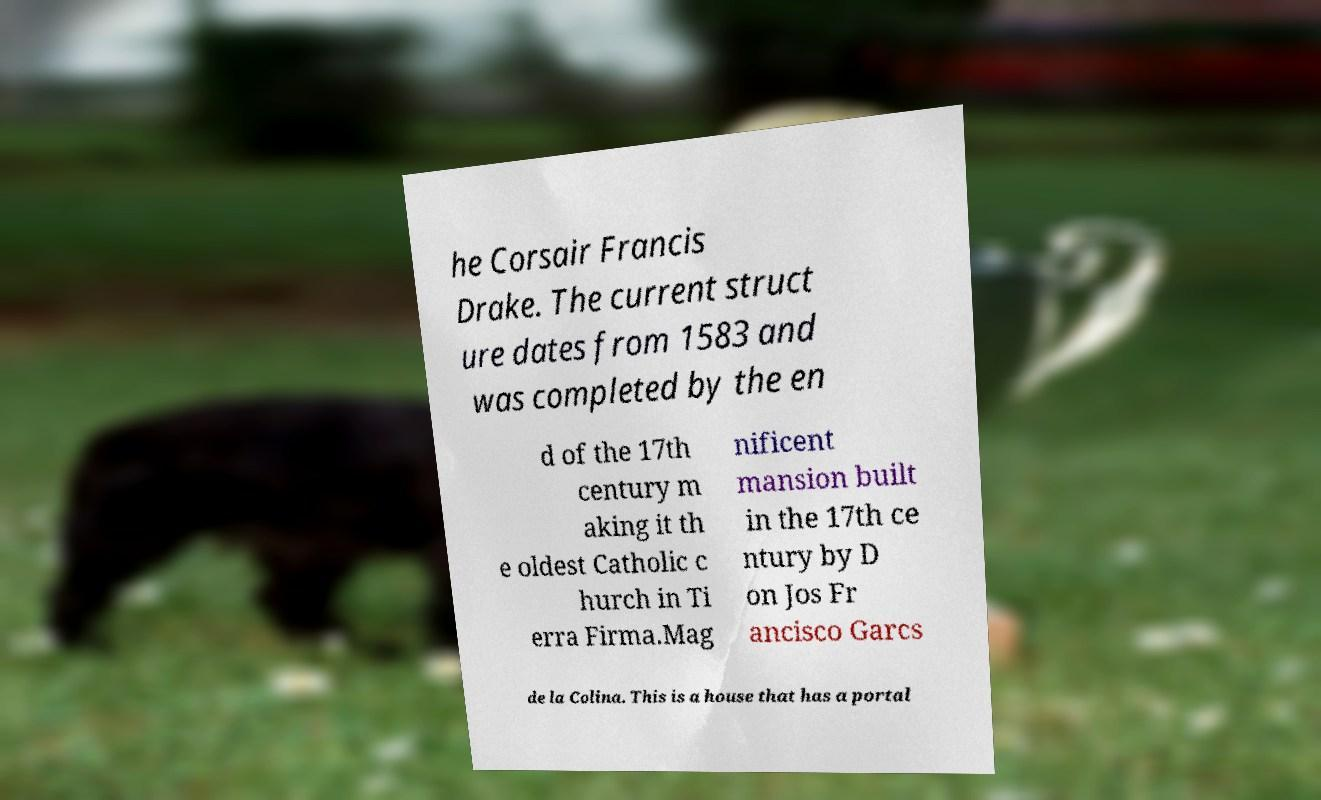What messages or text are displayed in this image? I need them in a readable, typed format. he Corsair Francis Drake. The current struct ure dates from 1583 and was completed by the en d of the 17th century m aking it th e oldest Catholic c hurch in Ti erra Firma.Mag nificent mansion built in the 17th ce ntury by D on Jos Fr ancisco Garcs de la Colina. This is a house that has a portal 